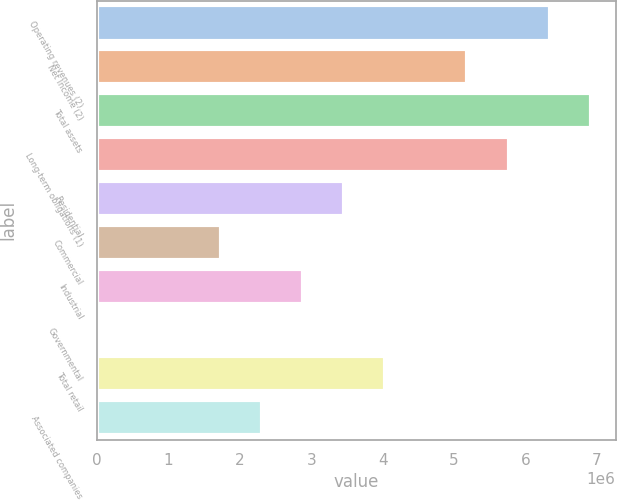<chart> <loc_0><loc_0><loc_500><loc_500><bar_chart><fcel>Operating revenues (2)<fcel>Net Income (2)<fcel>Total assets<fcel>Long-term obligations (1)<fcel>Residential<fcel>Commercial<fcel>Industrial<fcel>Governmental<fcel>Total retail<fcel>Associated companies<nl><fcel>6.33973e+06<fcel>5.18706e+06<fcel>6.91607e+06<fcel>5.7634e+06<fcel>3.45805e+06<fcel>1.72903e+06<fcel>2.88171e+06<fcel>21<fcel>4.03438e+06<fcel>2.30537e+06<nl></chart> 